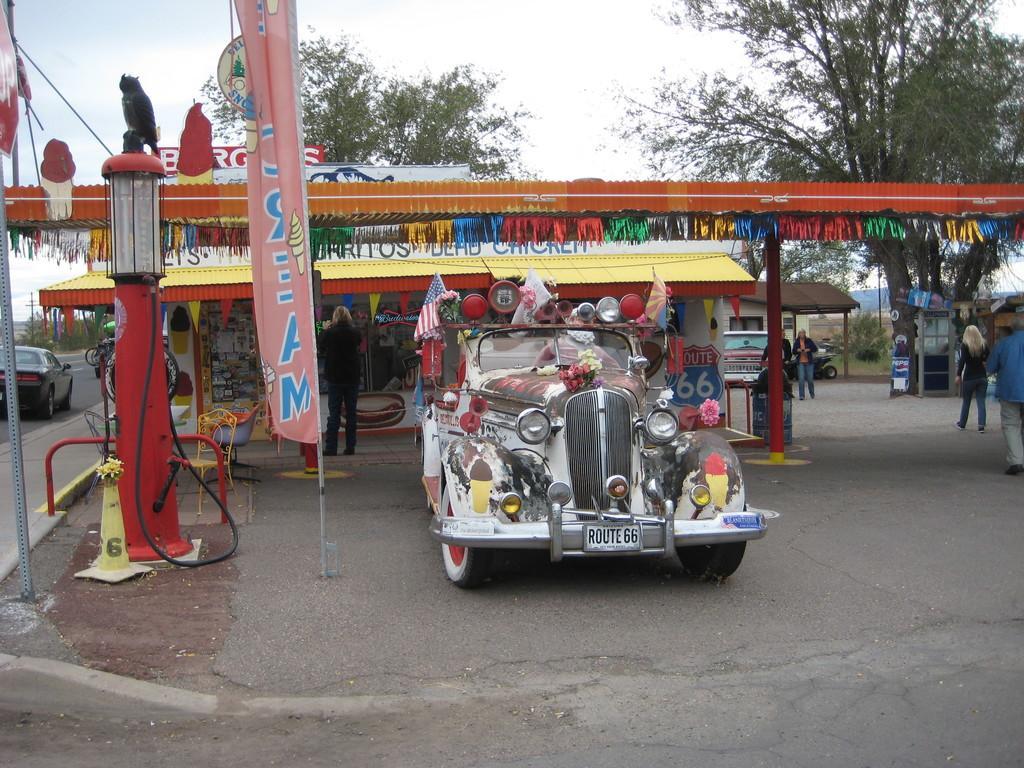In one or two sentences, can you explain what this image depicts? In this image I can see few vehicles and I can see group of people standing. In front the vehicle is in multicolor. In the background I can see the stall, few trees in green color and the sky is in white color. 